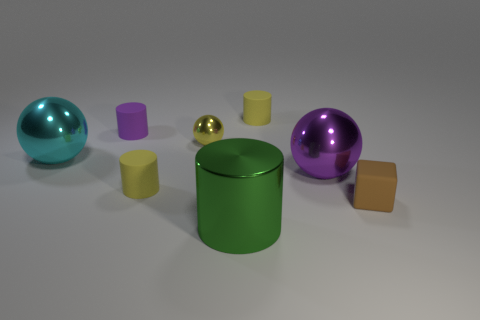Are there fewer blue balls than rubber cylinders?
Make the answer very short. Yes. What is the shape of the tiny object that is to the left of the small yellow cylinder that is in front of the big metal sphere on the left side of the large cylinder?
Offer a very short reply. Cylinder. How many objects are brown things that are behind the large cylinder or tiny yellow objects that are in front of the small purple thing?
Your answer should be very brief. 3. There is a cyan metallic sphere; are there any metallic balls in front of it?
Offer a very short reply. Yes. What number of objects are cyan things in front of the tiny purple matte object or small yellow rubber spheres?
Provide a short and direct response. 1. What number of blue objects are cylinders or big cylinders?
Your response must be concise. 0. How many other objects are the same color as the big metal cylinder?
Give a very brief answer. 0. Is the number of tiny brown rubber cubes on the right side of the brown thing less than the number of yellow metallic cubes?
Your answer should be very brief. No. There is a matte object that is in front of the yellow matte cylinder that is left of the small thing behind the purple cylinder; what is its color?
Provide a succinct answer. Brown. What size is the purple shiny thing that is the same shape as the tiny yellow metallic thing?
Your answer should be very brief. Large. 